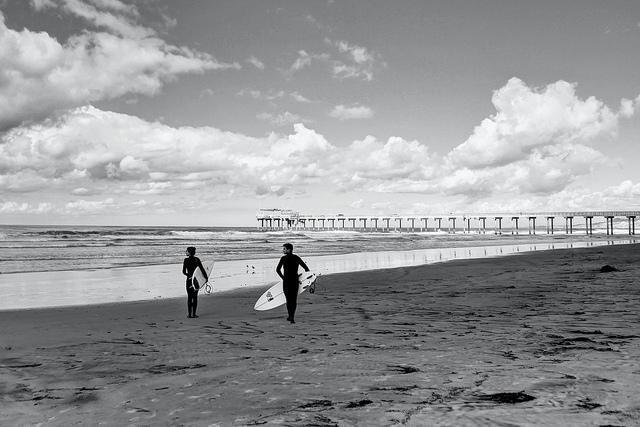How many people are in this scene?
Give a very brief answer. 2. 